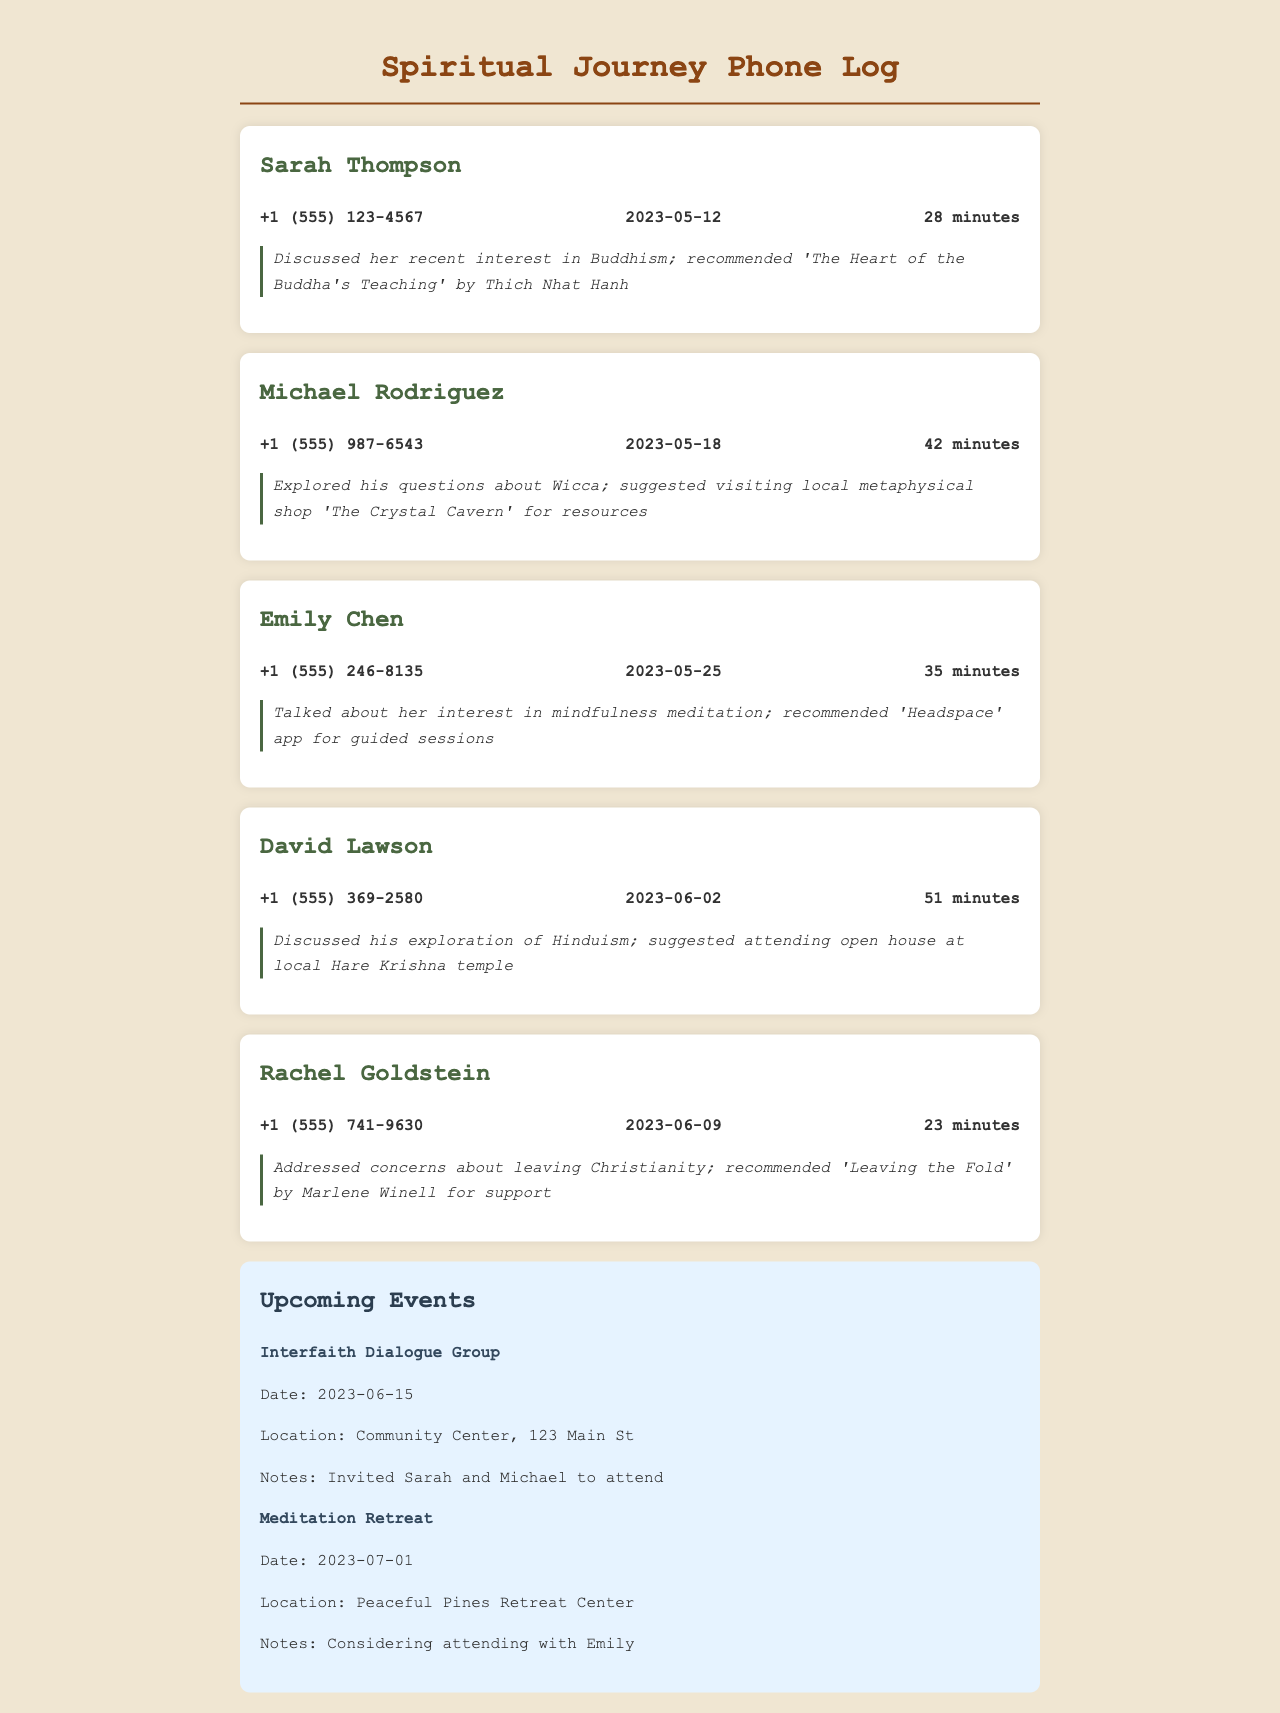What is the date of Sarah Thompson's call? The date is mentioned in the contact log next to her name.
Answer: 2023-05-12 How long was the call with Michael Rodriguez? The duration of the call is specified in minutes in the contact details for Michael.
Answer: 42 minutes What did Emily Chen express interest in? The note for Emily's call contains specific information about her interest.
Answer: mindfulness meditation What book was recommended to Rachel Goldstein? The recommendation for Rachel is clearly stated in the notes section of her call log.
Answer: Leaving the Fold What type of event is scheduled for 2023-06-15? The upcoming events section lists details about the event scheduled on that date.
Answer: Interfaith Dialogue Group Who is considering attending the Meditation Retreat with Emily? The notes section for the upcoming event indicates who may accompany Emily.
Answer: Considering attending with Emily What is the phone number for David Lawson? David's contact details include his phone number, which is specified in the contact log.
Answer: +1 (555) 369-2580 Which location is mentioned for the Meditation Retreat? The location for the Meditation Retreat is mentioned in the events section.
Answer: Peaceful Pines Retreat Center How many contacts are listed in the document? The number of contact logs can be counted from the contact entries shown.
Answer: Five contacts 